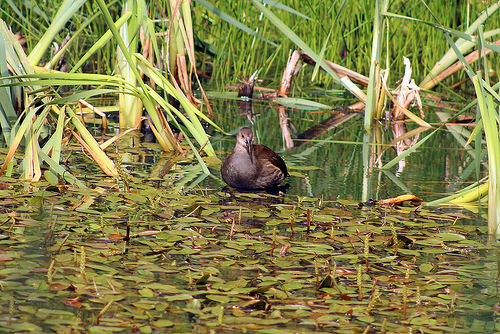<image>
Is there a duck above the water? No. The duck is not positioned above the water. The vertical arrangement shows a different relationship. 